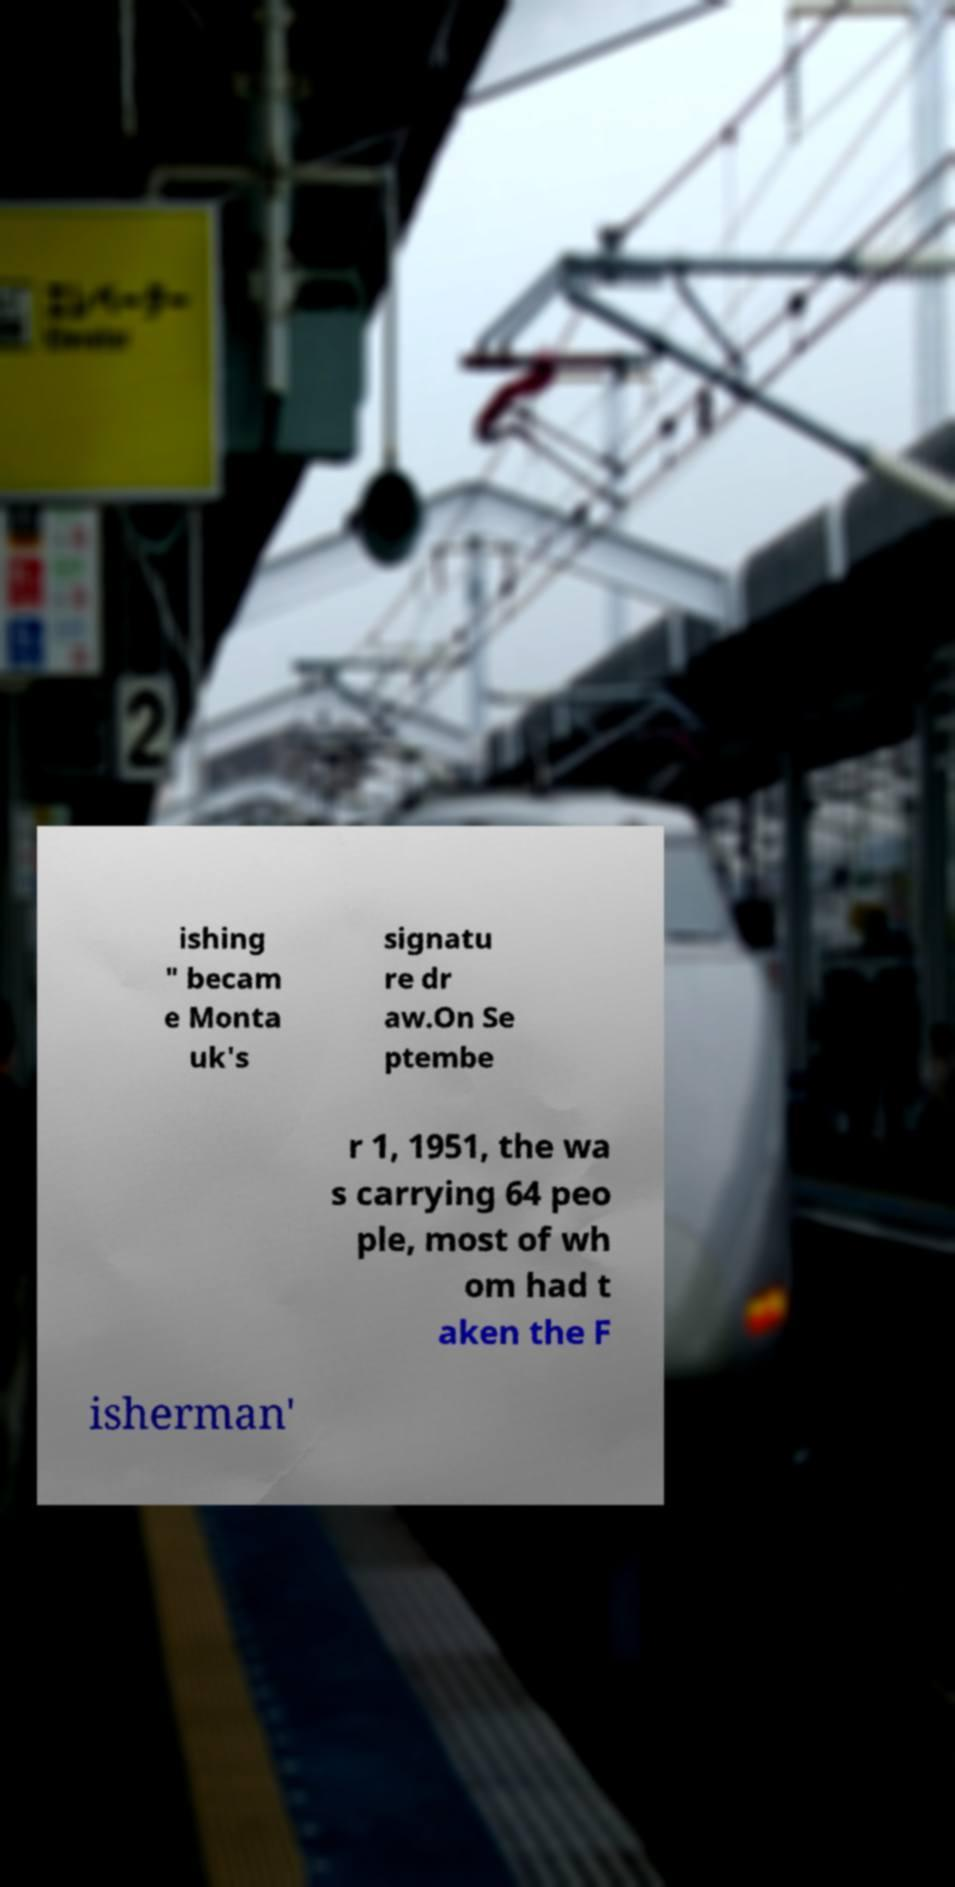There's text embedded in this image that I need extracted. Can you transcribe it verbatim? ishing " becam e Monta uk's signatu re dr aw.On Se ptembe r 1, 1951, the wa s carrying 64 peo ple, most of wh om had t aken the F isherman' 